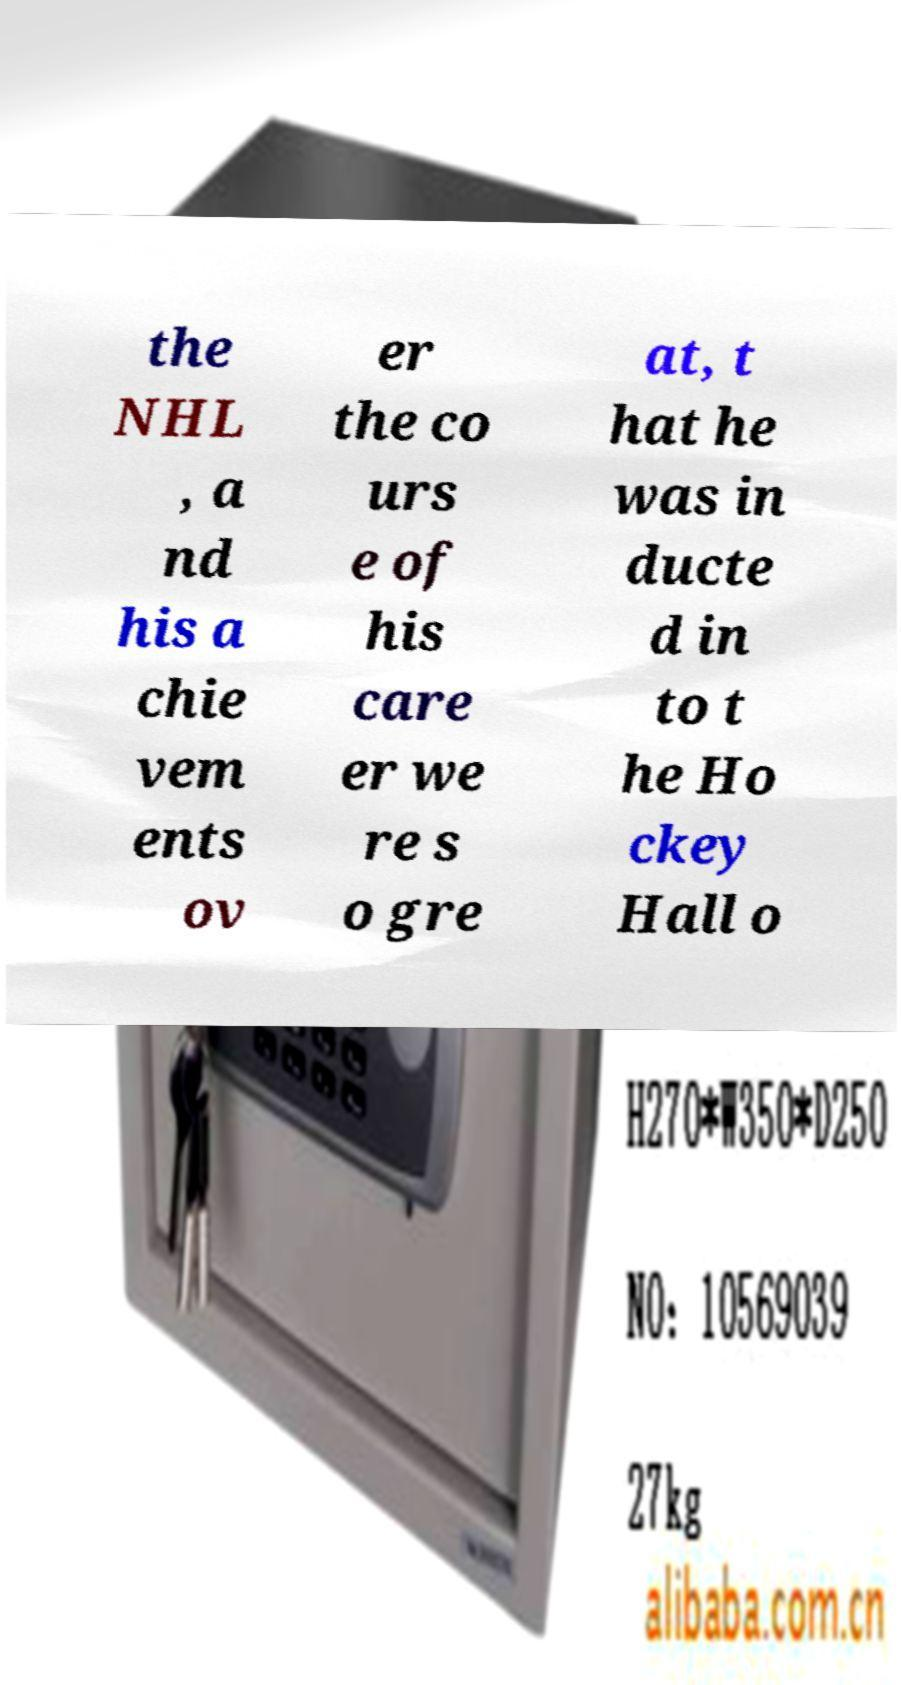Could you assist in decoding the text presented in this image and type it out clearly? the NHL , a nd his a chie vem ents ov er the co urs e of his care er we re s o gre at, t hat he was in ducte d in to t he Ho ckey Hall o 